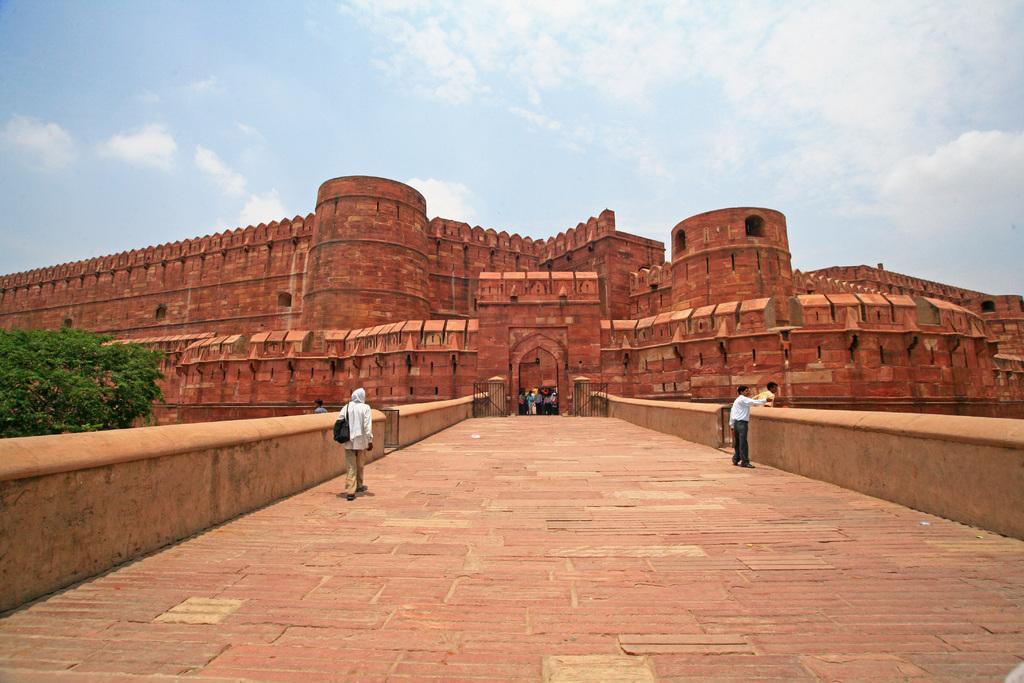Describe this image in one or two sentences. In the center of the image we can see an arch and a group of people are standing. In the background of the image we can see a fort. On the left and right side of the image we can see the wall. On the left side of the image we can see a tree and a man is walking and wearing dress, bag. On the right side of the image we can see a man is standing and holding a kid. At the bottom of the image we can see the floor. At the top of the image we can see the clouds are present in the sky. 